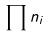<formula> <loc_0><loc_0><loc_500><loc_500>\prod n _ { i }</formula> 